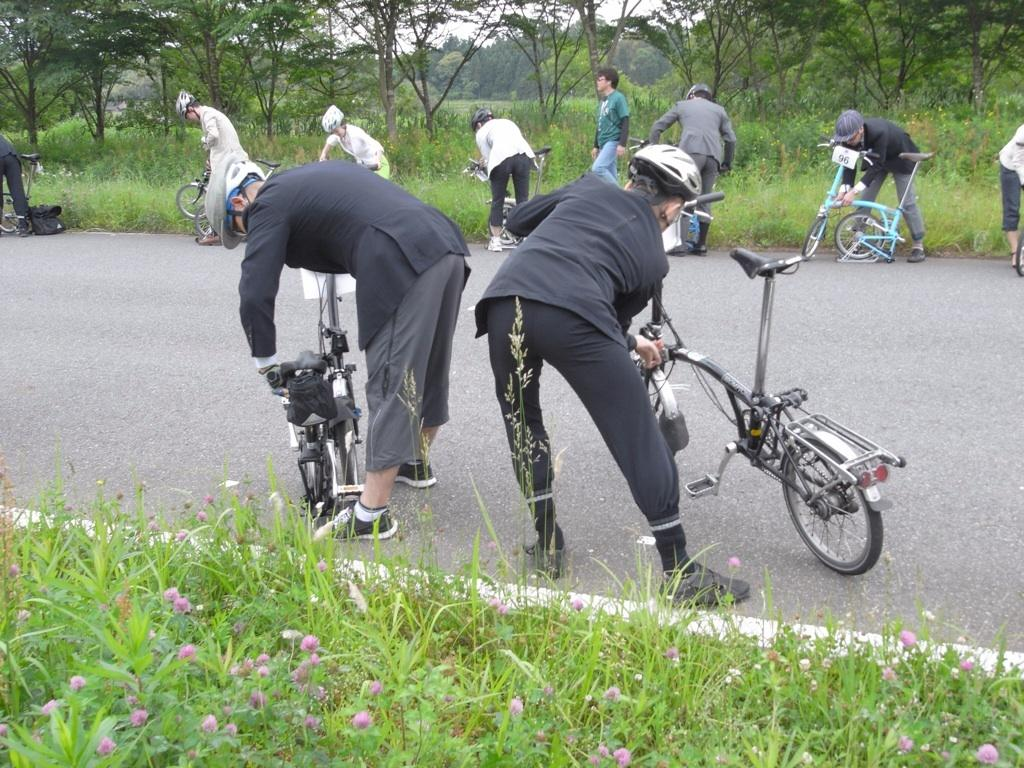What are the people in the image doing? The people in the image are standing and holding bicycles. What type of vegetation can be seen in the image? There are green plants and trees in the image. What is visible in the background of the image? The sky is visible in the image. What type of wax can be seen dripping from the trees in the image? There is no wax present in the image; the trees are not depicted as dripping wax. 